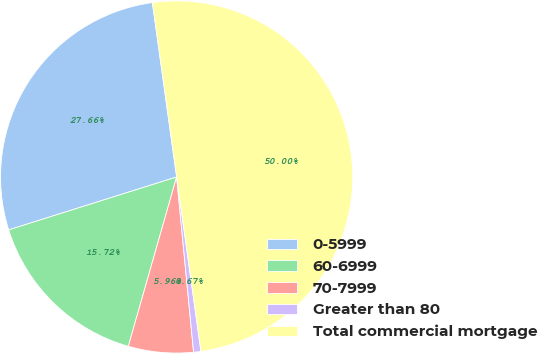<chart> <loc_0><loc_0><loc_500><loc_500><pie_chart><fcel>0-5999<fcel>60-6999<fcel>70-7999<fcel>Greater than 80<fcel>Total commercial mortgage<nl><fcel>27.66%<fcel>15.72%<fcel>5.96%<fcel>0.67%<fcel>50.0%<nl></chart> 